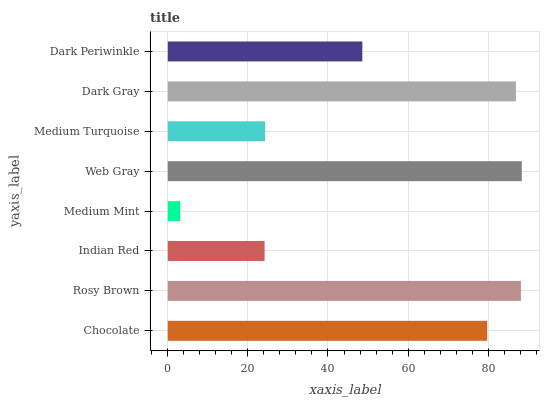Is Medium Mint the minimum?
Answer yes or no. Yes. Is Web Gray the maximum?
Answer yes or no. Yes. Is Rosy Brown the minimum?
Answer yes or no. No. Is Rosy Brown the maximum?
Answer yes or no. No. Is Rosy Brown greater than Chocolate?
Answer yes or no. Yes. Is Chocolate less than Rosy Brown?
Answer yes or no. Yes. Is Chocolate greater than Rosy Brown?
Answer yes or no. No. Is Rosy Brown less than Chocolate?
Answer yes or no. No. Is Chocolate the high median?
Answer yes or no. Yes. Is Dark Periwinkle the low median?
Answer yes or no. Yes. Is Dark Periwinkle the high median?
Answer yes or no. No. Is Chocolate the low median?
Answer yes or no. No. 